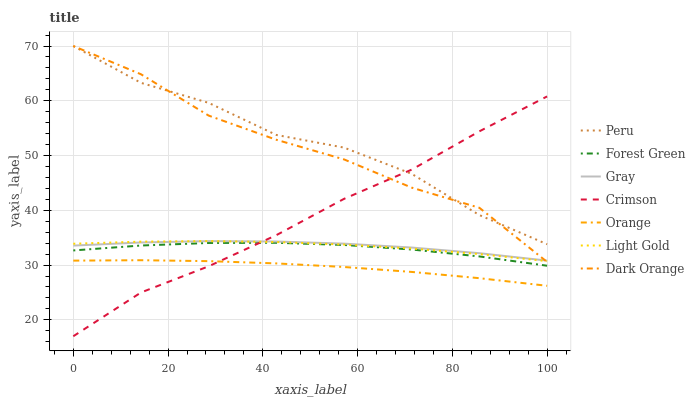Does Dark Orange have the minimum area under the curve?
Answer yes or no. No. Does Dark Orange have the maximum area under the curve?
Answer yes or no. No. Is Dark Orange the smoothest?
Answer yes or no. No. Is Dark Orange the roughest?
Answer yes or no. No. Does Dark Orange have the lowest value?
Answer yes or no. No. Does Orange have the highest value?
Answer yes or no. No. Is Forest Green less than Peru?
Answer yes or no. Yes. Is Peru greater than Forest Green?
Answer yes or no. Yes. Does Forest Green intersect Peru?
Answer yes or no. No. 